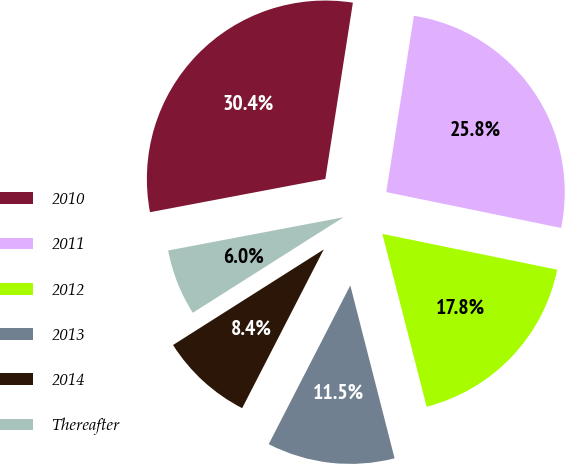Convert chart. <chart><loc_0><loc_0><loc_500><loc_500><pie_chart><fcel>2010<fcel>2011<fcel>2012<fcel>2013<fcel>2014<fcel>Thereafter<nl><fcel>30.45%<fcel>25.75%<fcel>17.79%<fcel>11.55%<fcel>8.45%<fcel>6.01%<nl></chart> 